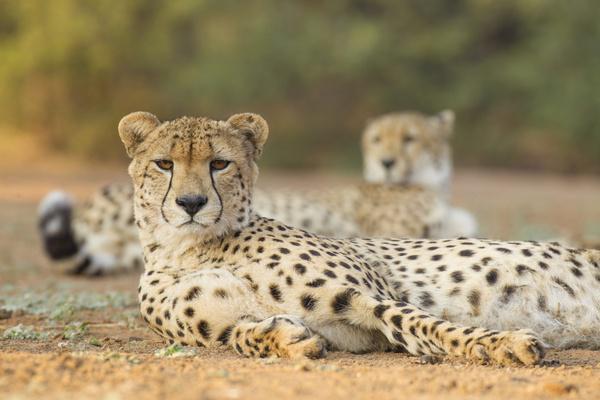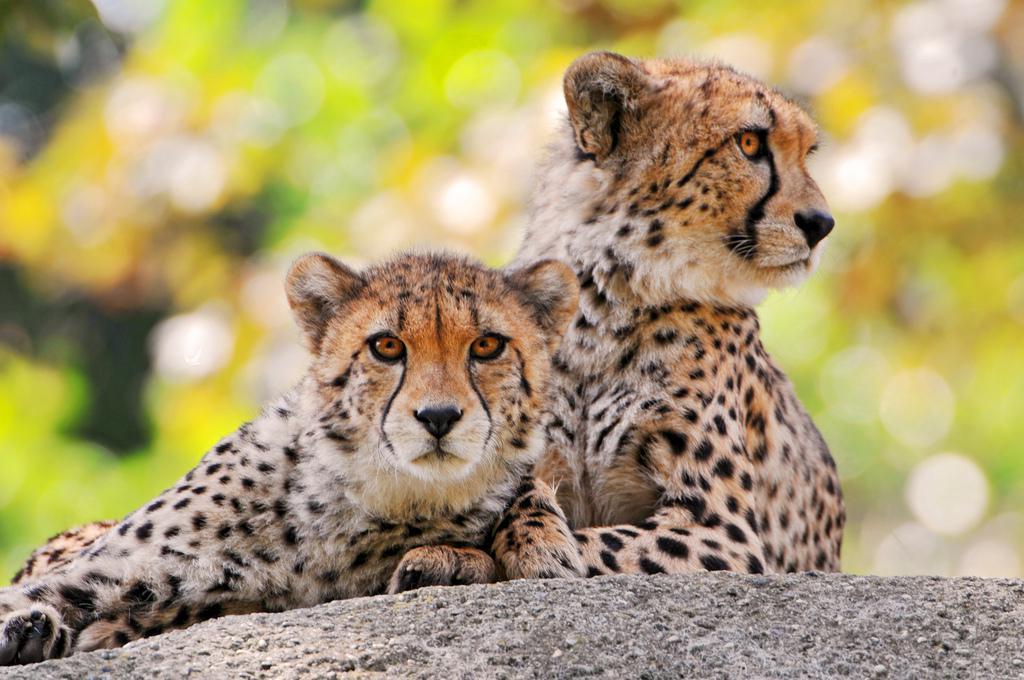The first image is the image on the left, the second image is the image on the right. Given the left and right images, does the statement "An image shows one spotted wild cat licking the face of another wild cat." hold true? Answer yes or no. No. The first image is the image on the left, the second image is the image on the right. Evaluate the accuracy of this statement regarding the images: "The left image contains a cheetah licking another cheetah.". Is it true? Answer yes or no. No. 